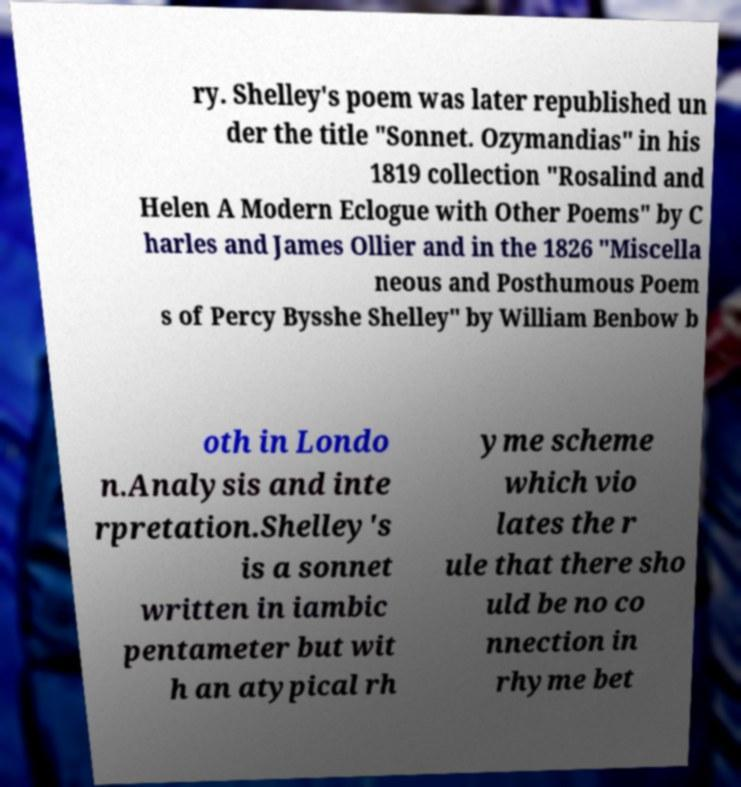There's text embedded in this image that I need extracted. Can you transcribe it verbatim? ry. Shelley's poem was later republished un der the title "Sonnet. Ozymandias" in his 1819 collection "Rosalind and Helen A Modern Eclogue with Other Poems" by C harles and James Ollier and in the 1826 "Miscella neous and Posthumous Poem s of Percy Bysshe Shelley" by William Benbow b oth in Londo n.Analysis and inte rpretation.Shelley's is a sonnet written in iambic pentameter but wit h an atypical rh yme scheme which vio lates the r ule that there sho uld be no co nnection in rhyme bet 